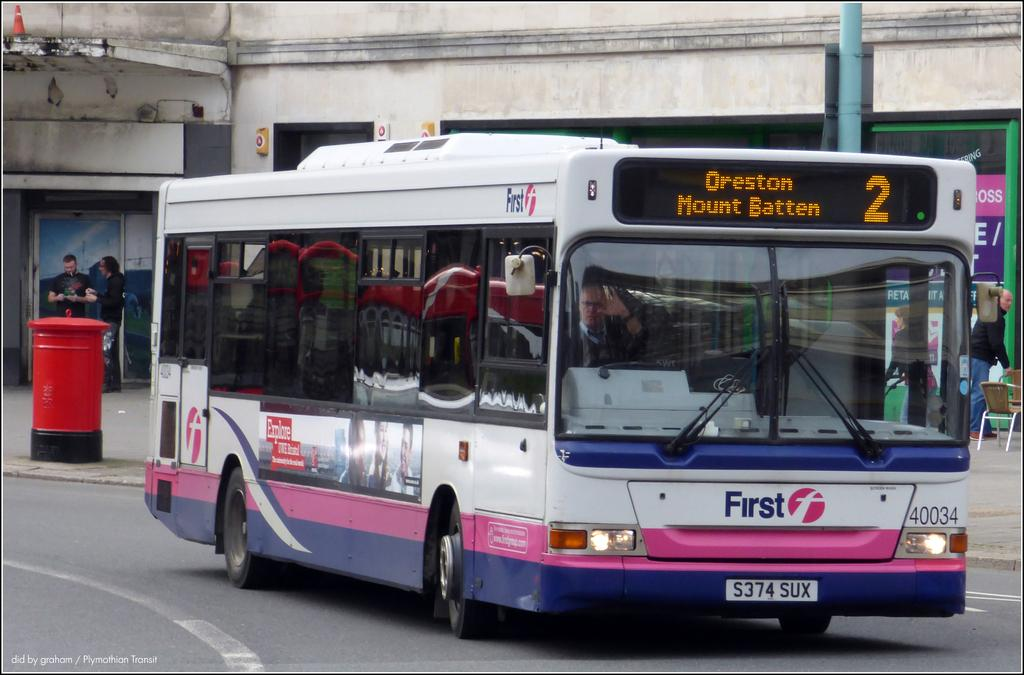<image>
Create a compact narrative representing the image presented. The white bus with pink and blue stripes is a number 2/ 